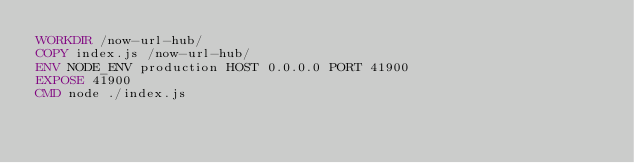<code> <loc_0><loc_0><loc_500><loc_500><_Dockerfile_>WORKDIR /now-url-hub/
COPY index.js /now-url-hub/
ENV NODE_ENV production HOST 0.0.0.0 PORT 41900
EXPOSE 41900
CMD node ./index.js
</code> 